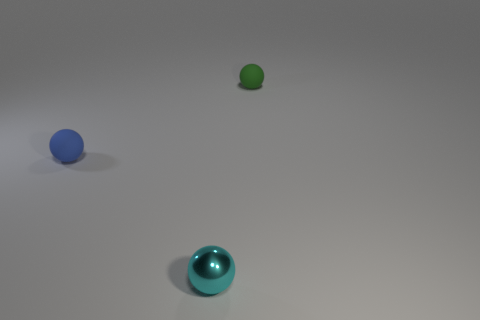The blue object has what shape?
Your answer should be very brief. Sphere. What number of other objects are the same material as the cyan sphere?
Your answer should be very brief. 0. What size is the cyan thing that is the same shape as the tiny green thing?
Give a very brief answer. Small. What is the cyan thing in front of the thing that is behind the rubber object that is in front of the green rubber thing made of?
Your answer should be very brief. Metal. Are any big yellow rubber spheres visible?
Keep it short and to the point. No. The metal sphere has what color?
Your response must be concise. Cyan. What is the color of the other rubber thing that is the same shape as the green matte thing?
Your response must be concise. Blue. Is the shape of the cyan metallic thing the same as the small blue rubber object?
Offer a very short reply. Yes. What number of cylinders are either tiny green matte objects or blue rubber things?
Ensure brevity in your answer.  0. What color is the other object that is the same material as the green thing?
Provide a succinct answer. Blue. 